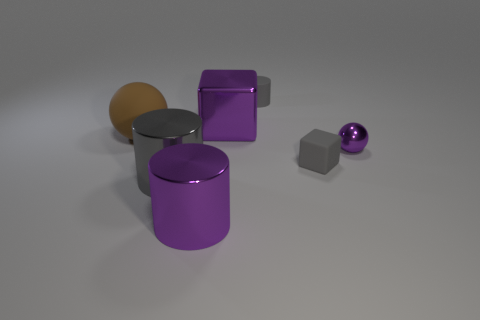Are there fewer large red spheres than large purple metal cubes? Based on the image, there are no large red spheres present at all, so the count would be zero. In contrast, there appears to be one large purple metal cube visible. Therefore, the statement that there are fewer large red spheres than large purple metal cubes is accurate, as zero is indeed less than one. 